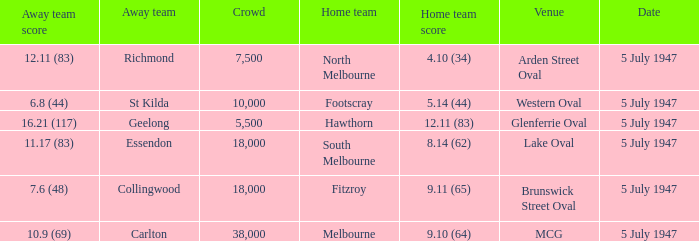Where was the game played where the away team has a score of 7.6 (48)? Brunswick Street Oval. 